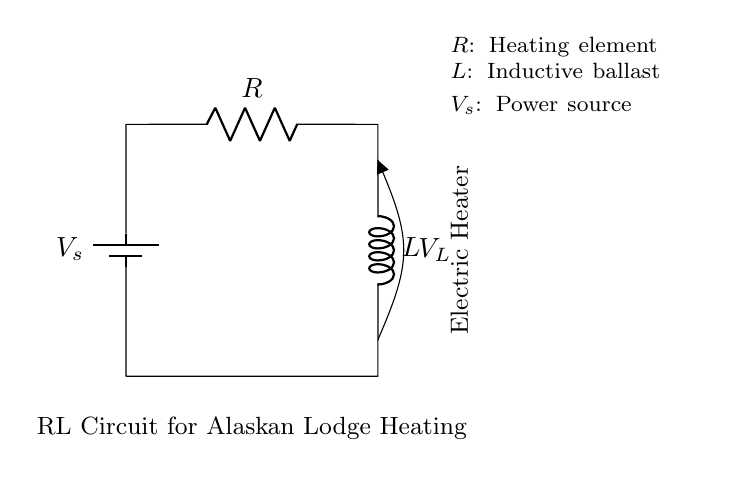What is the type of circuit shown? The circuit is a Resistor-Inductor circuit, which typically contains a resistor and an inductor as its primary components. This is evident from the labels in the circuit diagram indicating the presence of a resistor (R) and an inductor (L).
Answer: Resistor-Inductor What does R represent in this context? In this circuit, R represents the heating element, which is responsible for converting electrical energy into heat. The label next to the resistor in the diagram identifies it specifically as the heating element.
Answer: Heating element What is V_s in the circuit? V_s is the power source for the circuit, providing the necessary voltage for operation. The battery symbol in the diagram represents this power source, which supplies energy to the circuit.
Answer: Power source What is the purpose of the inductor in this circuit? The inductor (L) acts as an inductive ballast which can help in managing the current flow and preventing sudden surges when the electric heater activates. The labeled position and function in the circuit outline its key role.
Answer: Inductive ballast What is the voltage across the inductor denoted as? The voltage across the inductor is denoted as V_L, which indicates the potential difference specifically across the inductor. The circuit diagram shows this labeling directly next to the inductor component.
Answer: V_L How does the resistance affect heating in this circuit? The resistance (R) in the circuit directly affects the heating by determining how much current flows through the circuit when a voltage is applied. According to Ohm's law, higher resistance results in lower current, which reduces heating, while lower resistance allows more current flow, increasing heating.
Answer: Current flow What is the significance of the short in the circuit diagram? The short indicates a direct connection between the starting and ending points of the circuit, allowing current to flow back to the source without any resistance. This design is essential for creating a complete circuit loop, ensuring continuous operation of the heating element.
Answer: Complete circuit loop 